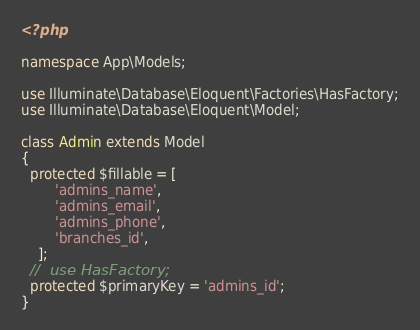Convert code to text. <code><loc_0><loc_0><loc_500><loc_500><_PHP_><?php

namespace App\Models;

use Illuminate\Database\Eloquent\Factories\HasFactory;
use Illuminate\Database\Eloquent\Model;

class Admin extends Model
{
  protected $fillable = [
        'admins_name',
        'admins_email',
        'admins_phone',
        'branches_id',
    ];
  //  use HasFactory;
  protected $primaryKey = 'admins_id';
}
</code> 